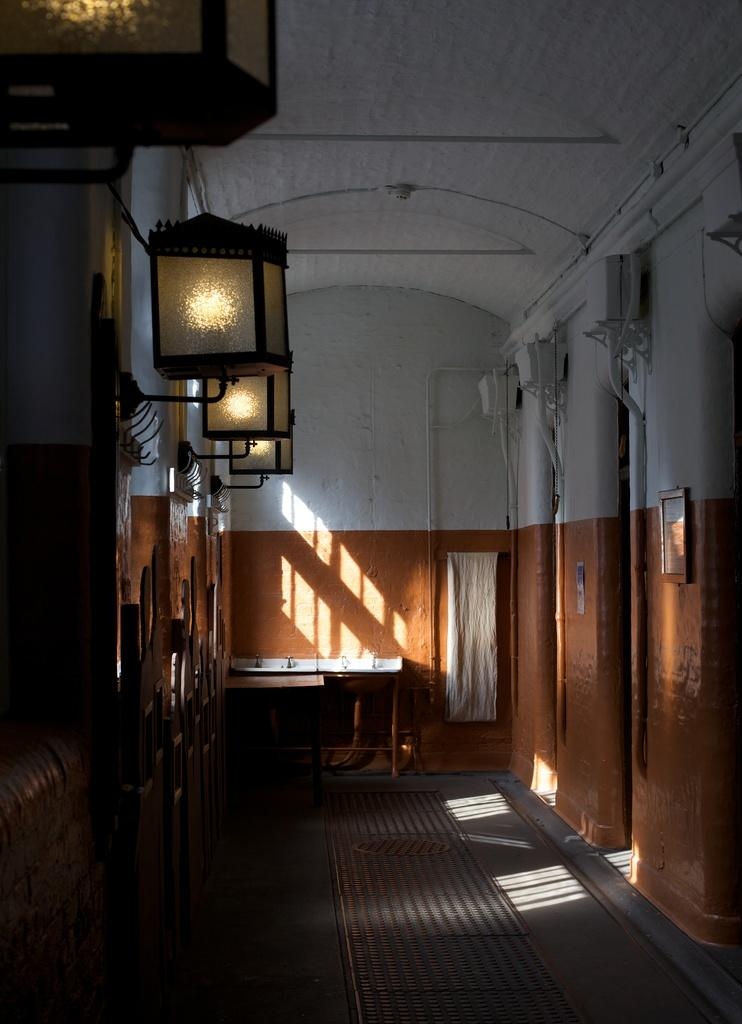What can be seen running through the center of the image? There is a path in the image. What is located on either side of the path? There are walls on both the left and right sides of the path. Are there any lights visible in the image? Yes, there are lights on the left side wall. What is present in the background of the image? There is a wall in the background of the image, and it has a sink associated with it. Can you see a lawyer tying a knot with a toothbrush in the image? No, there is no lawyer, knot, or toothbrush present in the image. 